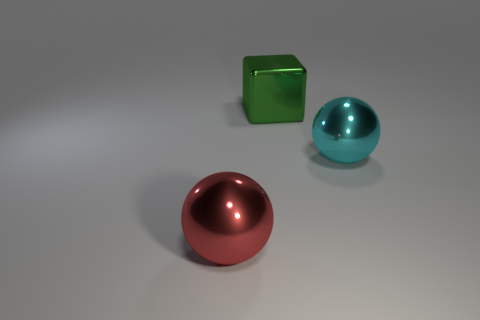What shape is the object that is in front of the green cube and right of the red metallic object?
Your answer should be compact. Sphere. Is there a cyan ball that has the same material as the large green cube?
Your response must be concise. Yes. Is the number of large cyan metallic objects right of the large metal cube the same as the number of metallic things that are behind the big cyan object?
Offer a very short reply. Yes. There is a thing that is in front of the large cyan metallic sphere; how big is it?
Offer a very short reply. Large. What number of metal spheres are to the left of the ball that is to the right of the shiny thing that is behind the cyan object?
Make the answer very short. 1. Is the material of the large sphere that is behind the red object the same as the big object behind the cyan shiny sphere?
Make the answer very short. Yes. What number of cyan metal objects are the same shape as the big red thing?
Ensure brevity in your answer.  1. Are there more objects in front of the big cyan thing than tiny cyan matte blocks?
Offer a terse response. Yes. What shape is the shiny object that is behind the large sphere right of the ball that is in front of the big cyan sphere?
Provide a succinct answer. Cube. Does the metallic thing in front of the big cyan metal thing have the same shape as the large metal thing that is right of the block?
Provide a succinct answer. Yes. 